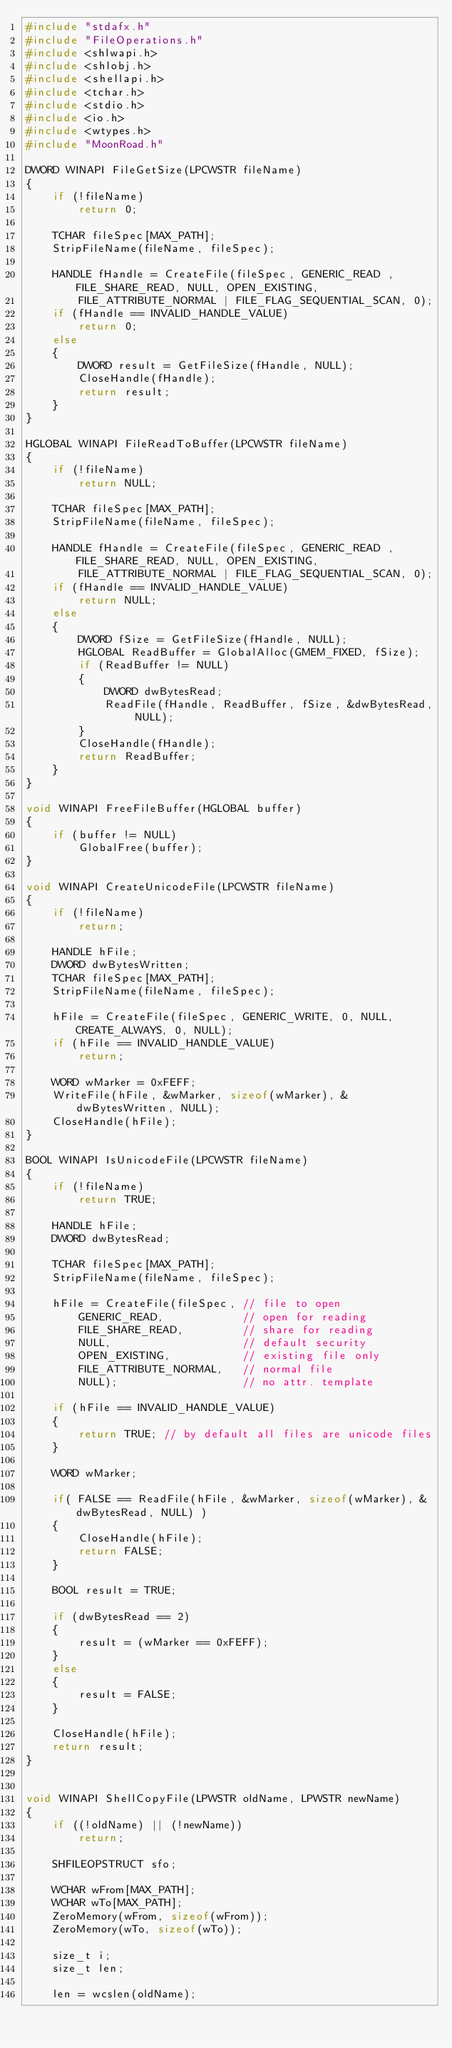Convert code to text. <code><loc_0><loc_0><loc_500><loc_500><_C++_>#include "stdafx.h"
#include "FileOperations.h"
#include <shlwapi.h>
#include <shlobj.h>
#include <shellapi.h>
#include <tchar.h>
#include <stdio.h>
#include <io.h>
#include <wtypes.h>
#include "MoonRoad.h"

DWORD WINAPI FileGetSize(LPCWSTR fileName)
{
	if (!fileName)
		return 0;

	TCHAR fileSpec[MAX_PATH];
	StripFileName(fileName, fileSpec);

	HANDLE fHandle = CreateFile(fileSpec, GENERIC_READ , FILE_SHARE_READ, NULL, OPEN_EXISTING,
		FILE_ATTRIBUTE_NORMAL | FILE_FLAG_SEQUENTIAL_SCAN, 0);
	if (fHandle == INVALID_HANDLE_VALUE)
		return 0;
	else
	{
		DWORD result = GetFileSize(fHandle, NULL);
		CloseHandle(fHandle);
		return result;
	}
}

HGLOBAL WINAPI FileReadToBuffer(LPCWSTR fileName)
{
	if (!fileName)
		return NULL;

	TCHAR fileSpec[MAX_PATH];
	StripFileName(fileName, fileSpec);

	HANDLE fHandle = CreateFile(fileSpec, GENERIC_READ , FILE_SHARE_READ, NULL, OPEN_EXISTING,
		FILE_ATTRIBUTE_NORMAL | FILE_FLAG_SEQUENTIAL_SCAN, 0);
	if (fHandle == INVALID_HANDLE_VALUE)
		return NULL;
	else
	{
		DWORD fSize = GetFileSize(fHandle, NULL);
		HGLOBAL ReadBuffer = GlobalAlloc(GMEM_FIXED, fSize);
		if (ReadBuffer != NULL)
		{
			DWORD dwBytesRead;
			ReadFile(fHandle, ReadBuffer, fSize, &dwBytesRead, NULL);
		}
		CloseHandle(fHandle);
		return ReadBuffer;
	}
}

void WINAPI FreeFileBuffer(HGLOBAL buffer)
{
	if (buffer != NULL)
		GlobalFree(buffer);
}

void WINAPI CreateUnicodeFile(LPCWSTR fileName)
{
	if (!fileName)
		return;

	HANDLE hFile;
	DWORD dwBytesWritten;
	TCHAR fileSpec[MAX_PATH];
	StripFileName(fileName, fileSpec);

	hFile = CreateFile(fileSpec, GENERIC_WRITE, 0, NULL, CREATE_ALWAYS, 0, NULL);
	if (hFile == INVALID_HANDLE_VALUE) 
		return;

	WORD wMarker = 0xFEFF;
	WriteFile(hFile, &wMarker, sizeof(wMarker), &dwBytesWritten, NULL);
	CloseHandle(hFile);
}

BOOL WINAPI IsUnicodeFile(LPCWSTR fileName)
{
	if (!fileName)
		return TRUE;

	HANDLE hFile;
	DWORD dwBytesRead;

	TCHAR fileSpec[MAX_PATH];
	StripFileName(fileName, fileSpec);

	hFile = CreateFile(fileSpec, // file to open
		GENERIC_READ,            // open for reading
		FILE_SHARE_READ,         // share for reading
		NULL,                    // default security
		OPEN_EXISTING,           // existing file only
		FILE_ATTRIBUTE_NORMAL,   // normal file
		NULL);                   // no attr. template

	if (hFile == INVALID_HANDLE_VALUE) 
	{ 
		return TRUE; // by default all files are unicode files
	}

	WORD wMarker;

	if( FALSE == ReadFile(hFile, &wMarker, sizeof(wMarker), &dwBytesRead, NULL) )
	{
		CloseHandle(hFile);
		return FALSE;
	}

	BOOL result = TRUE;

	if (dwBytesRead == 2)
	{
		result = (wMarker == 0xFEFF);
	}
	else
	{
		result = FALSE;
	}

	CloseHandle(hFile);
	return result;
}


void WINAPI ShellCopyFile(LPWSTR oldName, LPWSTR newName)
{
	if ((!oldName) || (!newName))
		return;

	SHFILEOPSTRUCT sfo;

	WCHAR wFrom[MAX_PATH];
	WCHAR wTo[MAX_PATH];
	ZeroMemory(wFrom, sizeof(wFrom));
	ZeroMemory(wTo, sizeof(wTo));

	size_t i;
	size_t len;

	len = wcslen(oldName);</code> 